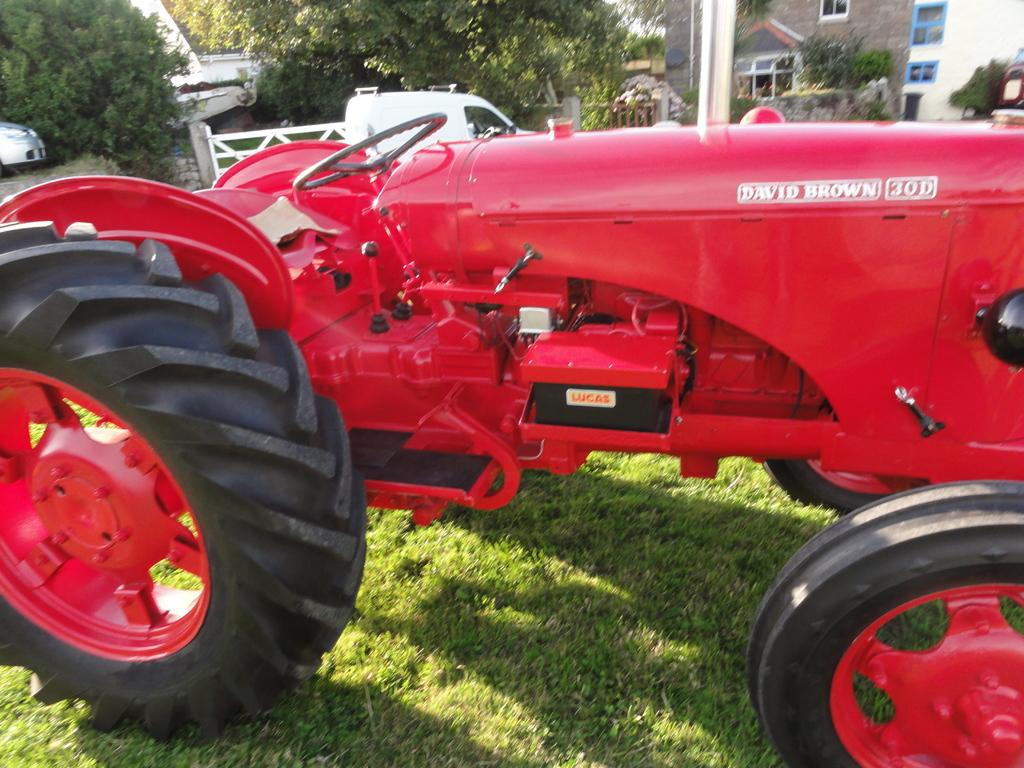What is the main subject of the image? There is a tractor in the image. What type of terrain is visible at the bottom of the image? There is grass at the bottom of the image. What can be seen in the background of the image? There are trees and a building in the background of the image. What other vehicle is present in the image? There is a car on the left side of the image. What type of care is being provided to the trees in the image? There is no indication of any care being provided to the trees in the image. Is there a group of people gathered around the tractor in the image? There is no group of people visible in the image. 